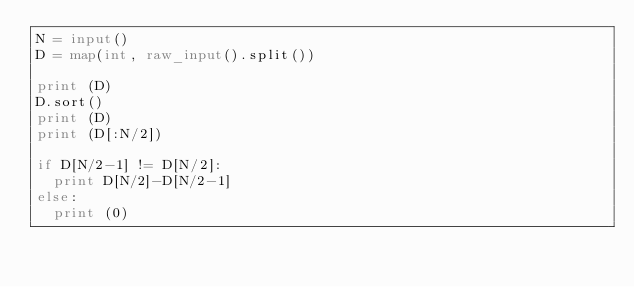Convert code to text. <code><loc_0><loc_0><loc_500><loc_500><_Python_>N = input()
D = map(int, raw_input().split())

print (D)
D.sort()
print (D)
print (D[:N/2])

if D[N/2-1] != D[N/2]:
  print D[N/2]-D[N/2-1]
else:
  print (0)</code> 